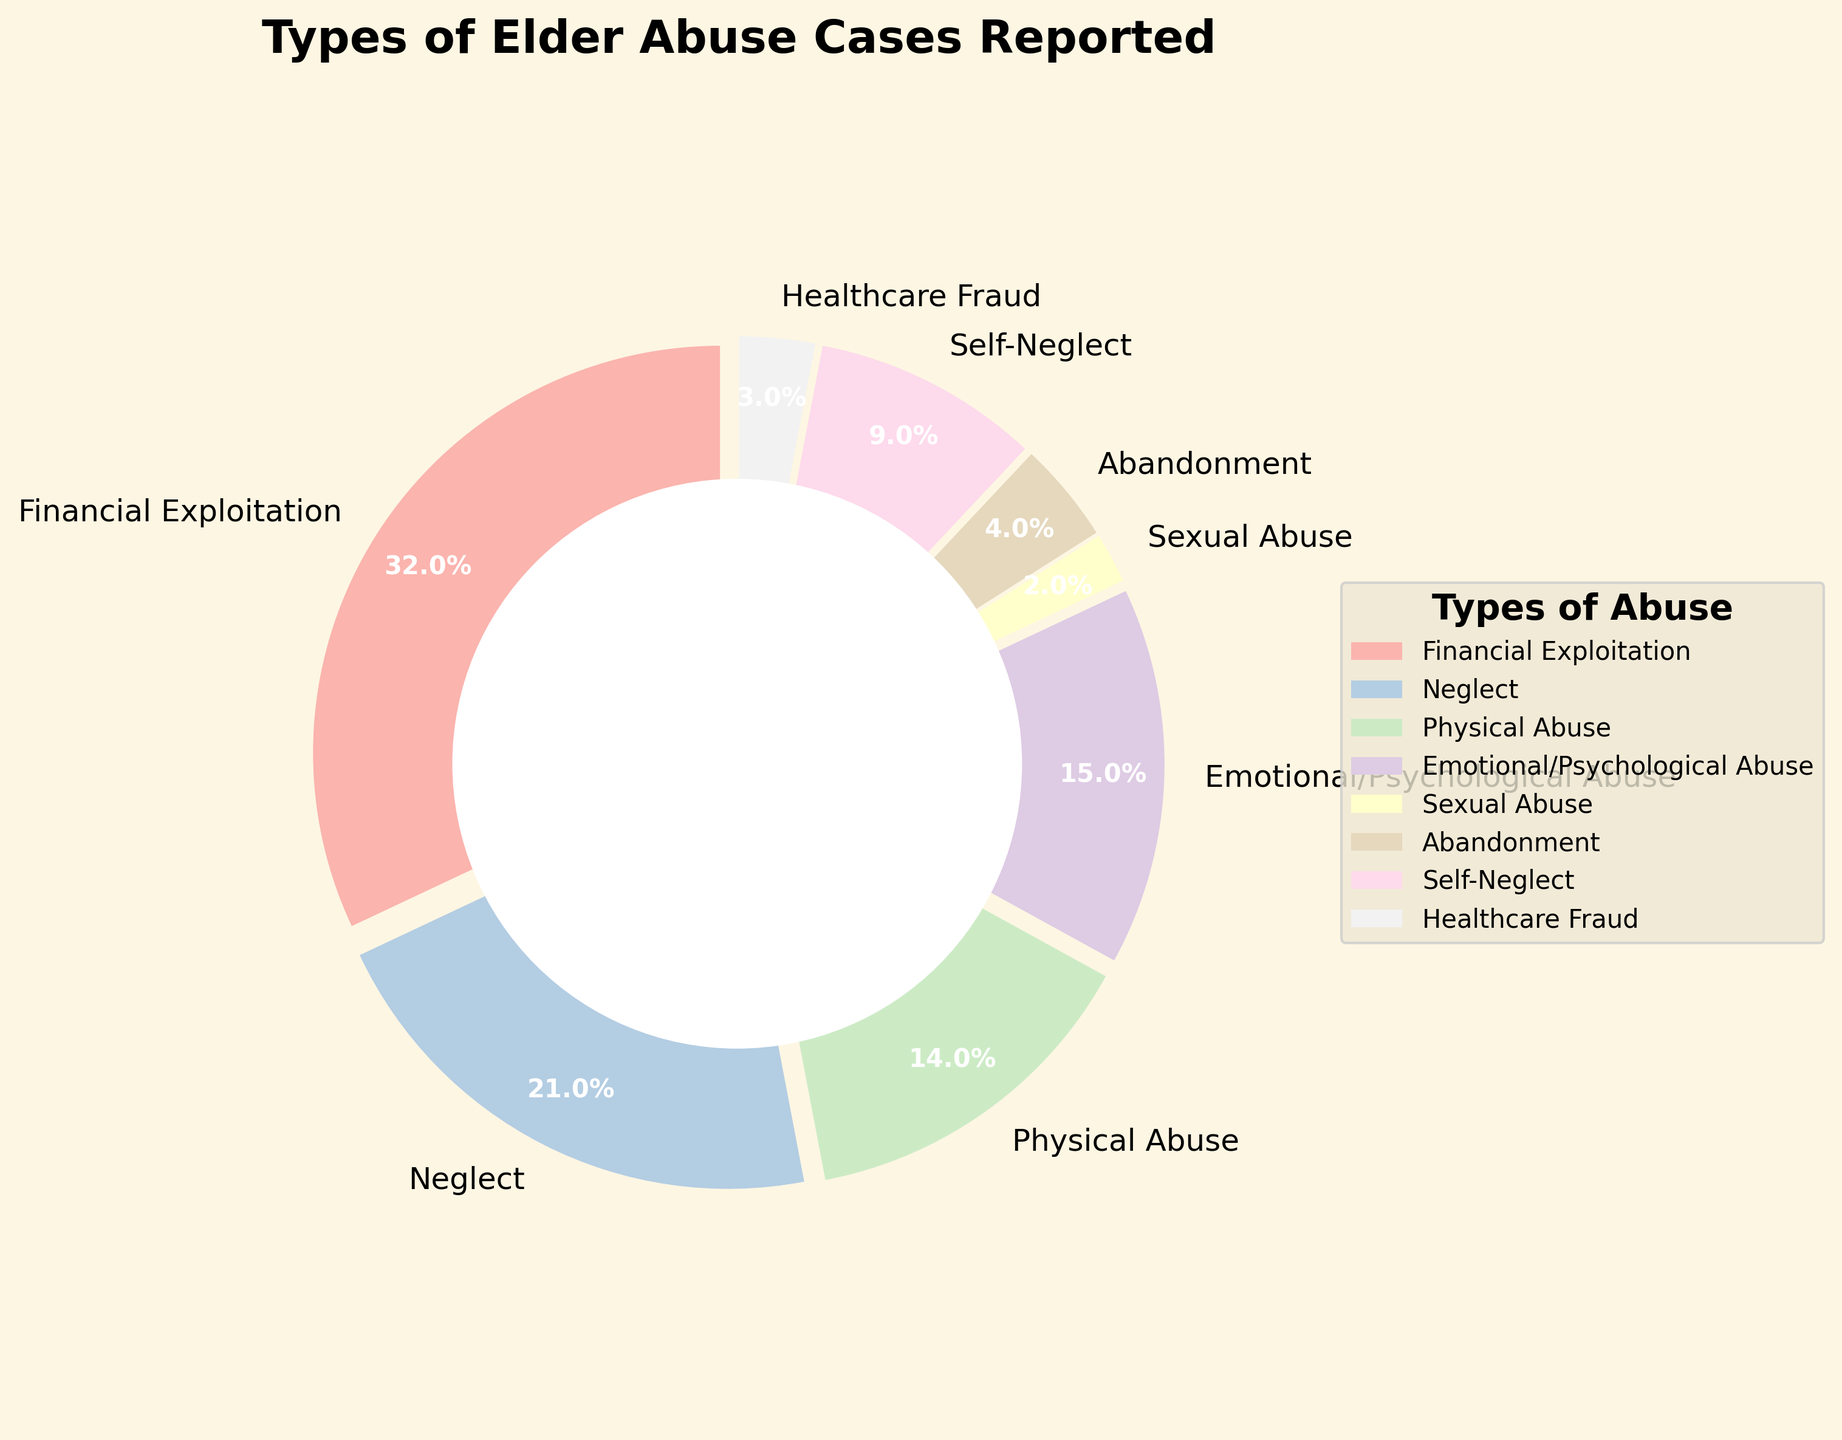How many types of elder abuse were reported? To find the total number of types reported, we count each category listed in the pie chart. The categories are Financial Exploitation, Neglect, Physical Abuse, Emotional/Psychological Abuse, Sexual Abuse, Abandonment, Self-Neglect, and Healthcare Fraud.
Answer: 8 Which type of elder abuse has the highest percentage? To determine the type with the highest percentage, we look for the slice of the pie chart with the largest proportion. Financial Exploitation is marked with 32%, the highest percentage among all categories.
Answer: Financial Exploitation What is the combined percentage of Physical Abuse and Neglect? To find the combined percentage, we add the percentages for Physical Abuse (14%) and Neglect (21%). 14 + 21 = 35%.
Answer: 35% Which types of elder abuse have a percentage less than 5%? We identify slices of the pie chart with percentages less than 5%. These are Sexual Abuse (2%), Abandonment (4%), and Healthcare Fraud (3%).
Answer: Sexual Abuse, Abandonment, Healthcare Fraud How does the percentage of Emotional/Psychological Abuse compare to Healthcare Fraud? We compare the slices representing both types. Emotional/Psychological Abuse is 15% while Healthcare Fraud is 3%. Since 15% is greater than 3%, Emotional/Psychological Abuse has a higher percentage.
Answer: Emotional/Psychological Abuse is higher What percentage of elder abuse cases fall under Self-Neglect? To find this, we note the percentage provided for Self-Neglect in the pie chart, which is 9%.
Answer: 9% What is the difference in percentage between Financial Exploitation and Emotional/Psychological Abuse? We subtract the percentage of Emotional/Psychological Abuse (15%) from Financial Exploitation (32%). 32 - 15 = 17%.
Answer: 17% What color represents Neglect in the pie chart? We look for the visual attribute that corresponds to the Neglect category in the legend of the pie chart. The Neglect slice is represented by a specific color.
Answer: The actual color (descriptive answer) What is the total percentage of cases involving Neglect, Abandonment, and Self-Neglect? We sum the percentages for Neglect (21%), Abandonment (4%), and Self-Neglect (9%). 21 + 4 + 9 = 34%.
Answer: 34% How many types of elder abuse cases have a percentage of 10% or higher? We count the types with slices representing 10% or higher: Financial Exploitation (32%), Neglect (21%), Physical Abuse (14%), and Emotional/Psychological Abuse (15%).
Answer: 4 